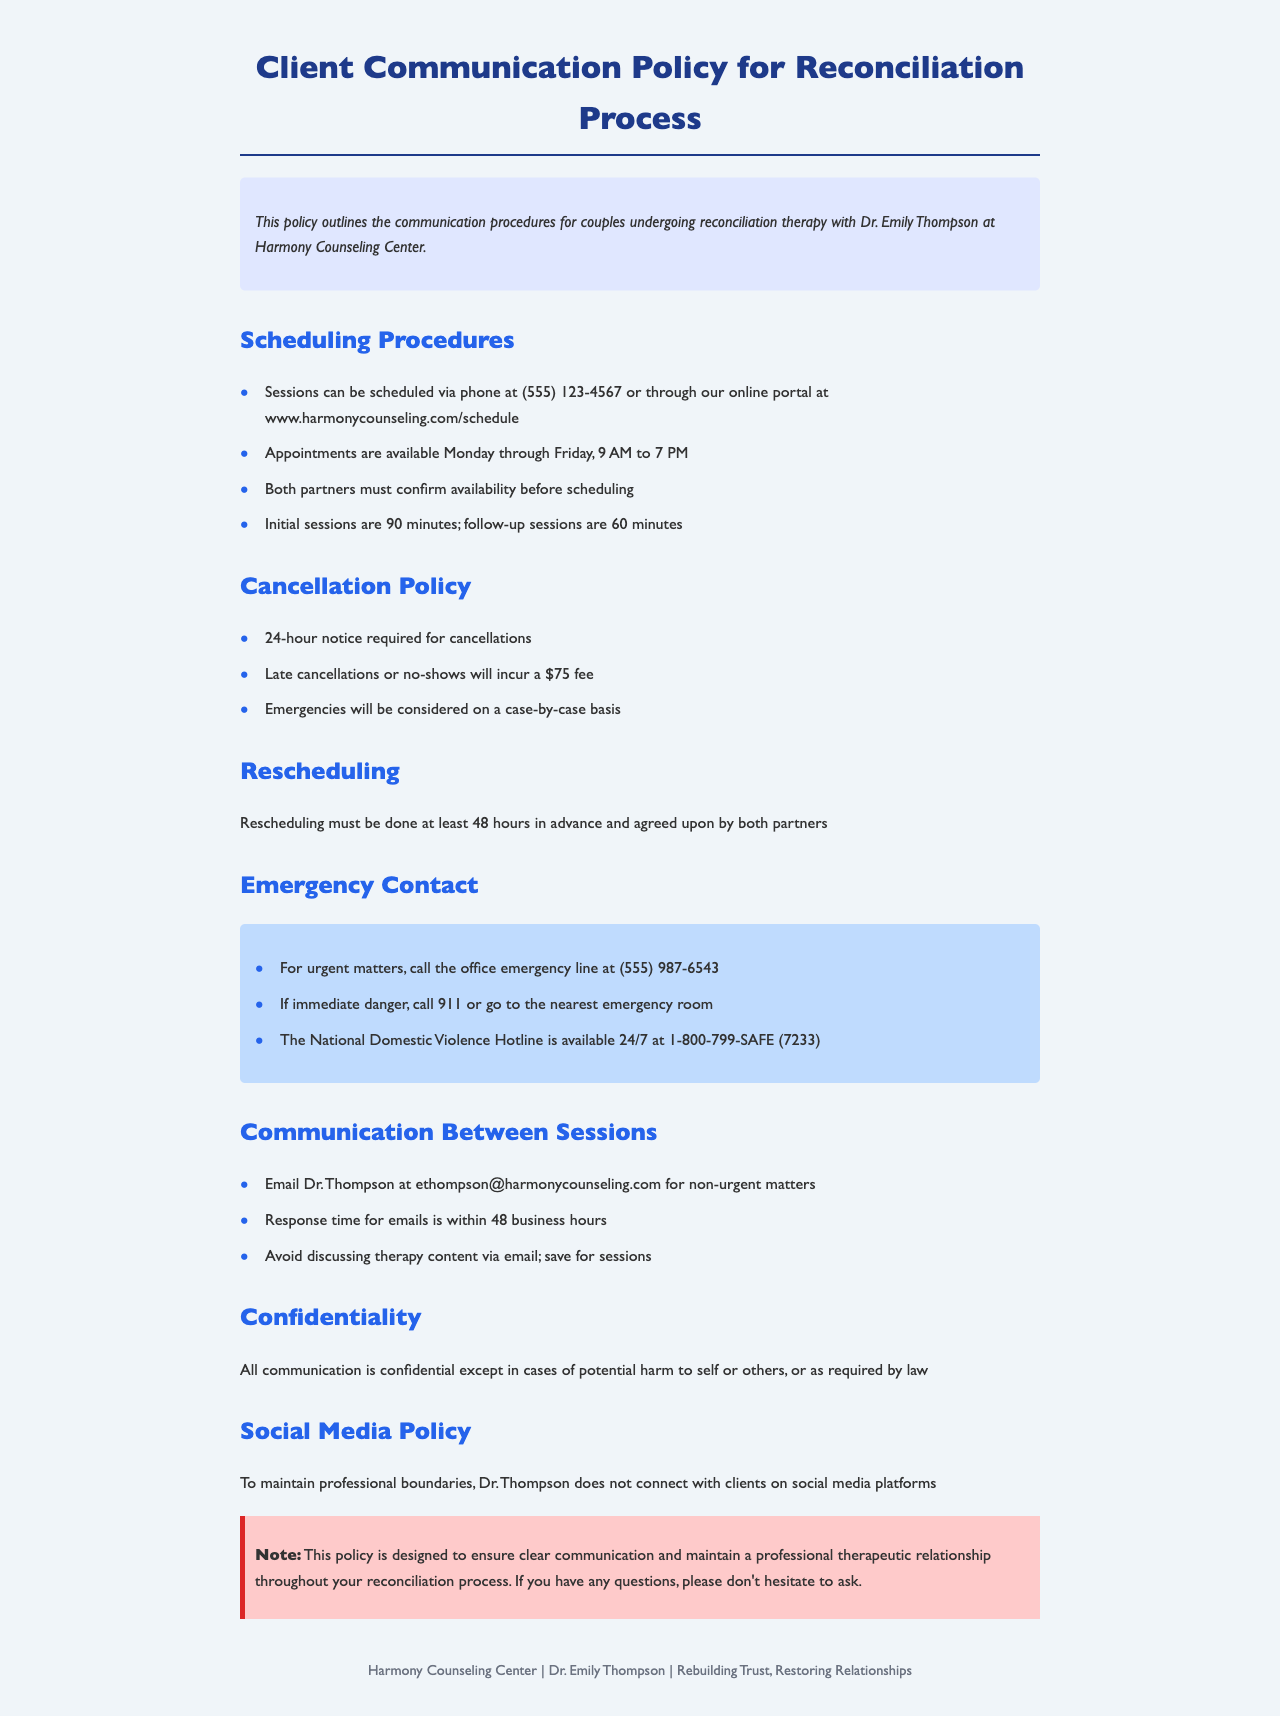What are the days available for appointments? The document states that appointments are available Monday through Friday.
Answer: Monday through Friday What is the fee for a late cancellation? The policy mentions that late cancellations or no-shows will incur a $75 fee.
Answer: $75 What should be done in immediate danger? The document advises to call 911 or go to the nearest emergency room.
Answer: Call 911 What is the email for non-urgent matters? The policy provides Dr. Thompson's email as ethompson@harmonycounseling.com for non-urgent matters.
Answer: ethompson@harmonycounseling.com How much notice is required for rescheduling? The policy states that rescheduling must be done at least 48 hours in advance.
Answer: 48 hours What is the response time for emails? The document specifies that the response time for emails is within 48 business hours.
Answer: Within 48 business hours What is the duration of initial sessions? The document states that initial sessions are 90 minutes long.
Answer: 90 minutes What is the consequence for discussing therapy content via email? The document advises to avoid discussing therapy content via email, indicating it should be saved for sessions.
Answer: Save for sessions 